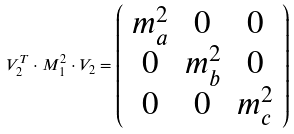<formula> <loc_0><loc_0><loc_500><loc_500>V _ { 2 } ^ { T } \cdot M _ { 1 } ^ { 2 } \cdot V _ { 2 } = \left ( \begin{array} { c c c } m _ { a } ^ { 2 } & 0 & 0 \\ 0 & m _ { b } ^ { 2 } & 0 \\ 0 & 0 & m _ { c } ^ { 2 } \end{array} \right )</formula> 